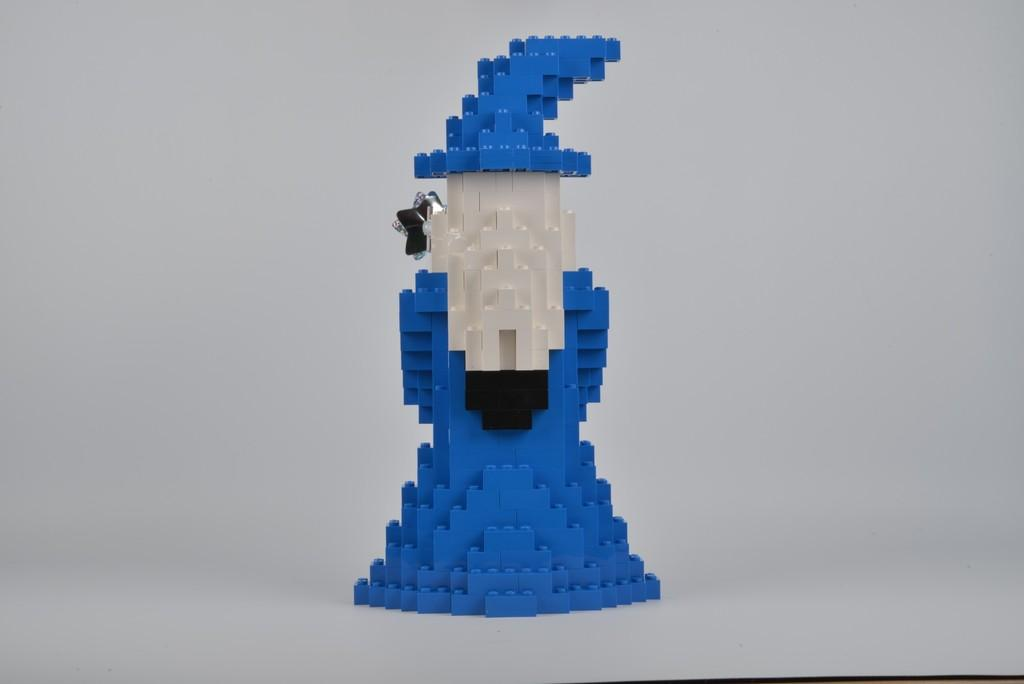What can be seen in the image? There is an object in the image. What colors are present on the object? The object has blue, black, and white colors. What color is the background of the image? The background of the image is white. What type of territory does the pet claim in the image? There is no pet present in the image, so there is no territory being claimed. 